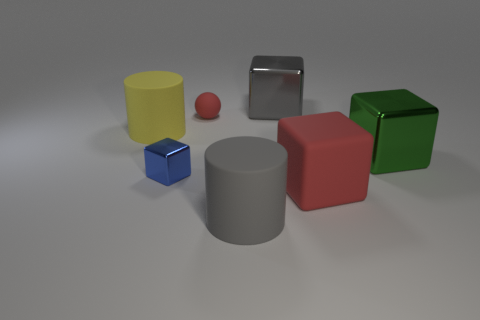Subtract all cyan cubes. Subtract all green balls. How many cubes are left? 4 Add 2 tiny red metallic objects. How many objects exist? 9 Subtract all blocks. How many objects are left? 3 Subtract all green shiny objects. Subtract all big red shiny blocks. How many objects are left? 6 Add 1 large gray things. How many large gray things are left? 3 Add 5 big yellow cylinders. How many big yellow cylinders exist? 6 Subtract 1 blue blocks. How many objects are left? 6 